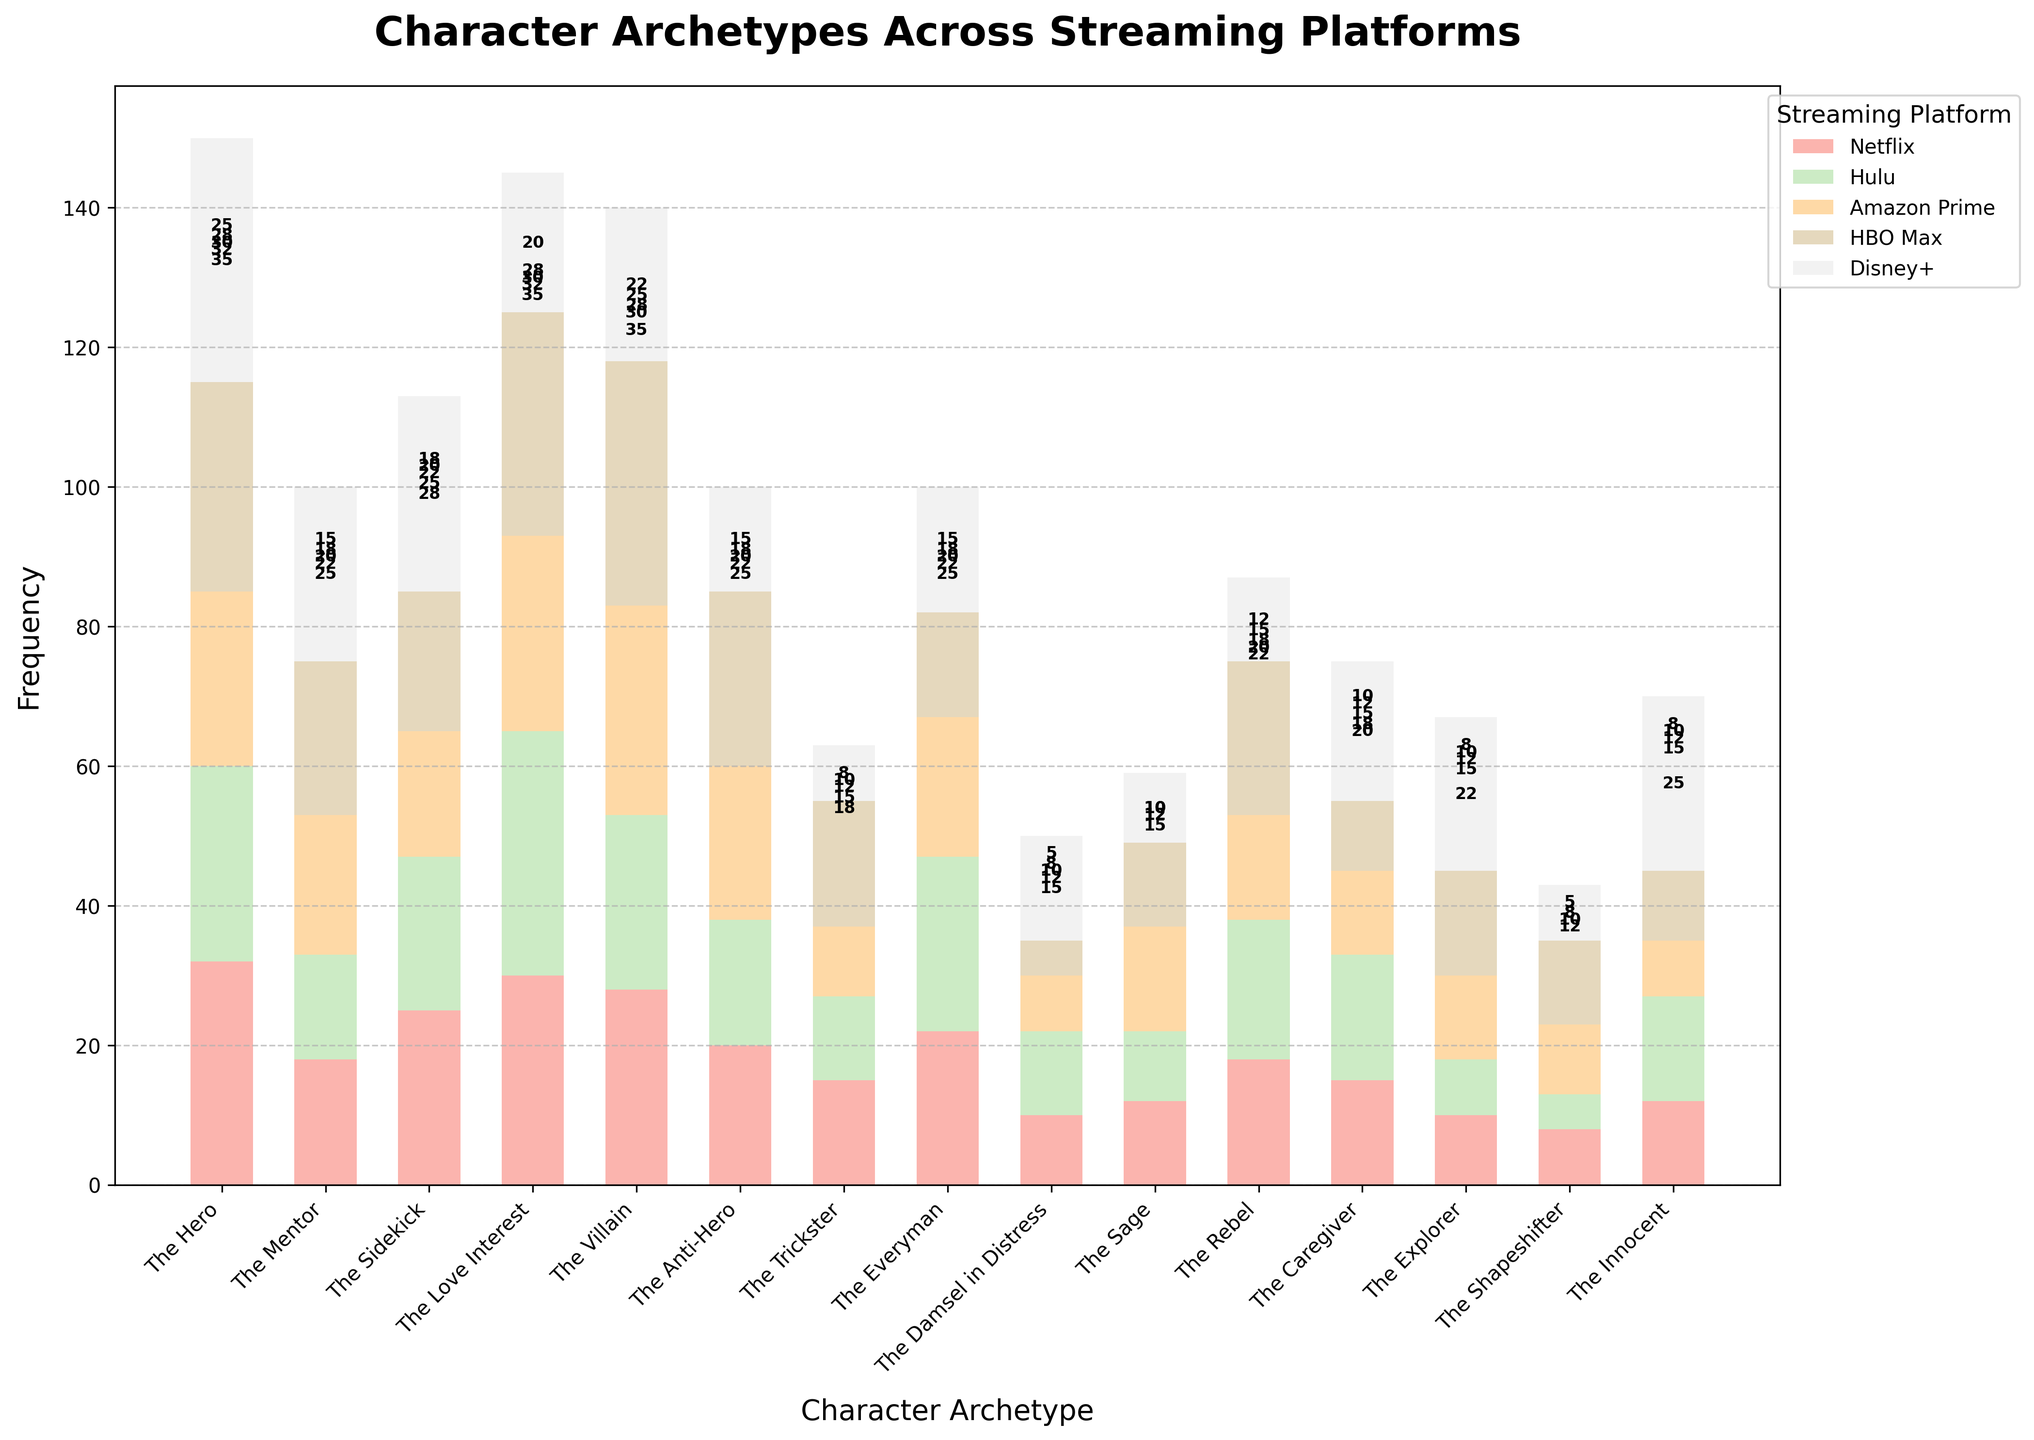What character archetype appears most frequently on HBO Max? By closely examining the bar heights, it is evident that "The Villain" archetype appears the most frequently on HBO Max, marked by the highest bar for HBO Max in the figure.
Answer: The Villain Which streaming platform has the least appearances of "The Explorer" archetype? Looking at the bars for the "The Explorer" archetype, the shortest bar is for Netflix with a height of 10, indicating it has the least appearances across the platforms.
Answer: Netflix What is the total frequency of "The Mentor" archetype across all platforms? Sum the frequencies for "The Mentor": Netflix (18) + Hulu (15) + Amazon Prime (20) + HBO Max (22) + Disney+ (25). 18 + 15 + 20 + 22 + 25 = 100.
Answer: 100 Compare the sum of "The Rebel" archetype on Netflix and Hulu with the sum on Amazon Prime and Disney+. Which sum is higher? Calculate the sum for Netflix and Hulu first (18 + 20 = 38) then compare with Amazon Prime and Disney+ (15 + 12 = 27). 38 is higher than 27.
Answer: Netflix and Hulu How does the frequency of "The Hero" on Disney+ compare to its frequency on Hulu? Observe the bar heights for "The Hero" archetype on both Disney+ and Hulu. The taller bar on Disney+ (35) compared to Hulu (28) indicates Disney+ has a higher frequency.
Answer: Disney+ is higher Which streaming platform features "The Innocent" archetype the most? By examining the height of the bars associated with "The Innocent" archetype, Disney+ has the tallest bar, meaning it features "The Innocent" the most.
Answer: Disney+ What is the difference in the frequency of "The Sidekick" between Amazon Prime and Disney+? Subtract the frequency of "The Sidekick" on Amazon Prime (18) from its frequency on Disney+ (28). 28 - 18 = 10.
Answer: 10 What is the average frequency of "The Shapeshifter" across all platforms? Sum the frequencies for "The Shapeshifter" across all platforms and divide by the number of platforms: (8 + 5 + 10 + 12 + 8) / 5. (8 + 5 + 10 + 12 + 8) = 43, 43 / 5 = 8.6.
Answer: 8.6 Which character archetype has the highest combined frequency across all platforms? Sum the total frequencies for each archetype across all platforms and identify the highest. "The Hero" has the highest sum: 32 + 28 + 25 + 30 + 35 = 150.
Answer: The Hero What is the median frequency of "The Villain" across all platforms? Arrange the frequencies for "The Villain" in ascending order: 22, 25, 28, 30, 35. The median (middle value) is 28.
Answer: 28 